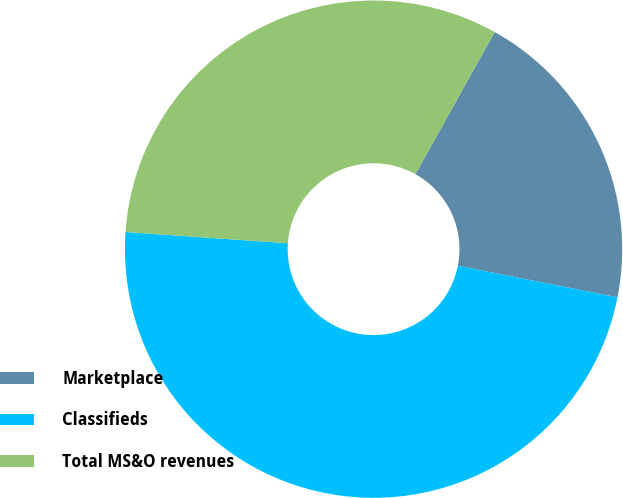<chart> <loc_0><loc_0><loc_500><loc_500><pie_chart><fcel>Marketplace<fcel>Classifieds<fcel>Total MS&O revenues<nl><fcel>20.0%<fcel>48.0%<fcel>32.0%<nl></chart> 